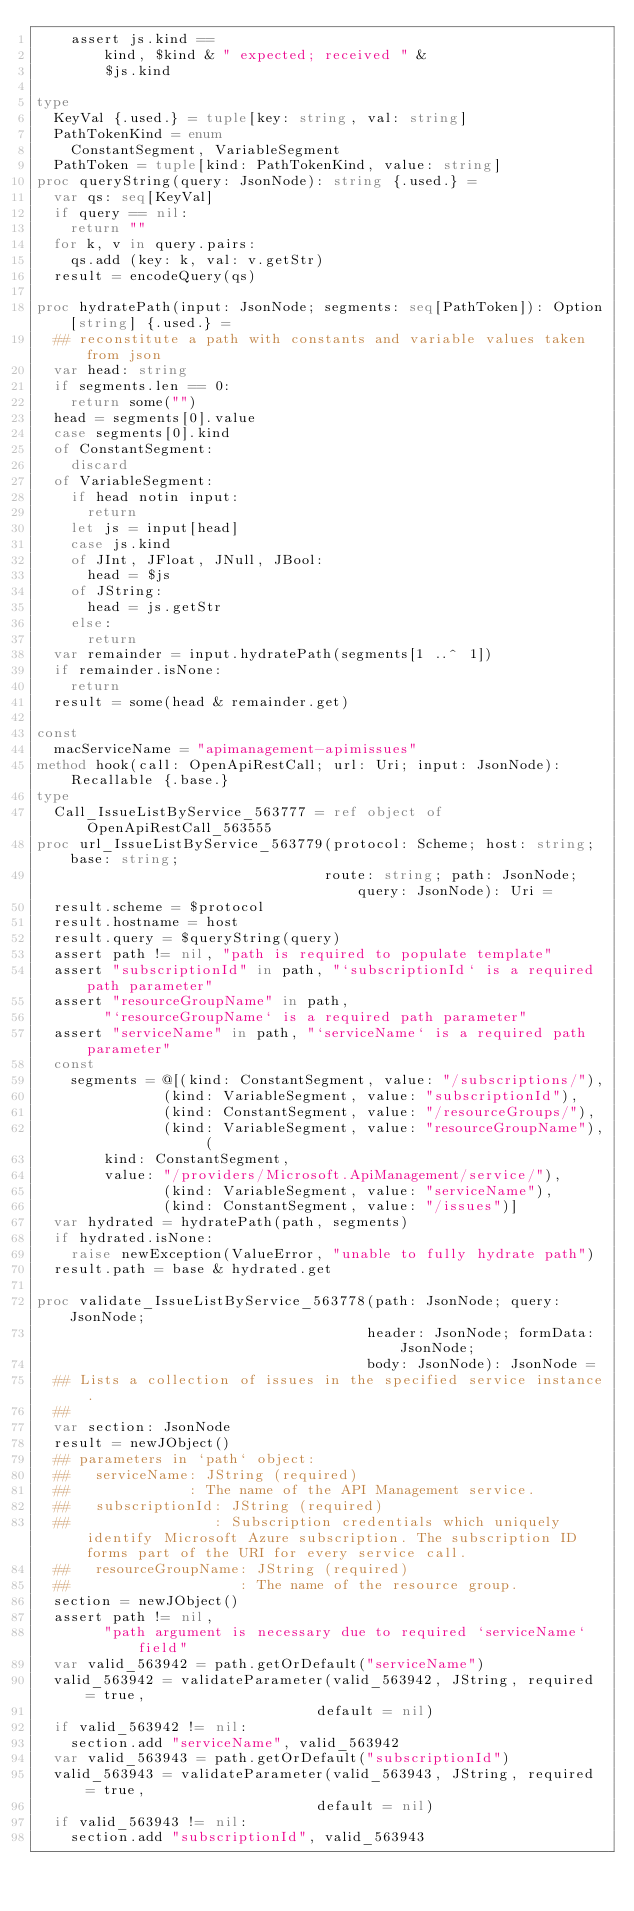Convert code to text. <code><loc_0><loc_0><loc_500><loc_500><_Nim_>    assert js.kind ==
        kind, $kind & " expected; received " &
        $js.kind

type
  KeyVal {.used.} = tuple[key: string, val: string]
  PathTokenKind = enum
    ConstantSegment, VariableSegment
  PathToken = tuple[kind: PathTokenKind, value: string]
proc queryString(query: JsonNode): string {.used.} =
  var qs: seq[KeyVal]
  if query == nil:
    return ""
  for k, v in query.pairs:
    qs.add (key: k, val: v.getStr)
  result = encodeQuery(qs)

proc hydratePath(input: JsonNode; segments: seq[PathToken]): Option[string] {.used.} =
  ## reconstitute a path with constants and variable values taken from json
  var head: string
  if segments.len == 0:
    return some("")
  head = segments[0].value
  case segments[0].kind
  of ConstantSegment:
    discard
  of VariableSegment:
    if head notin input:
      return
    let js = input[head]
    case js.kind
    of JInt, JFloat, JNull, JBool:
      head = $js
    of JString:
      head = js.getStr
    else:
      return
  var remainder = input.hydratePath(segments[1 ..^ 1])
  if remainder.isNone:
    return
  result = some(head & remainder.get)

const
  macServiceName = "apimanagement-apimissues"
method hook(call: OpenApiRestCall; url: Uri; input: JsonNode): Recallable {.base.}
type
  Call_IssueListByService_563777 = ref object of OpenApiRestCall_563555
proc url_IssueListByService_563779(protocol: Scheme; host: string; base: string;
                                  route: string; path: JsonNode; query: JsonNode): Uri =
  result.scheme = $protocol
  result.hostname = host
  result.query = $queryString(query)
  assert path != nil, "path is required to populate template"
  assert "subscriptionId" in path, "`subscriptionId` is a required path parameter"
  assert "resourceGroupName" in path,
        "`resourceGroupName` is a required path parameter"
  assert "serviceName" in path, "`serviceName` is a required path parameter"
  const
    segments = @[(kind: ConstantSegment, value: "/subscriptions/"),
               (kind: VariableSegment, value: "subscriptionId"),
               (kind: ConstantSegment, value: "/resourceGroups/"),
               (kind: VariableSegment, value: "resourceGroupName"), (
        kind: ConstantSegment,
        value: "/providers/Microsoft.ApiManagement/service/"),
               (kind: VariableSegment, value: "serviceName"),
               (kind: ConstantSegment, value: "/issues")]
  var hydrated = hydratePath(path, segments)
  if hydrated.isNone:
    raise newException(ValueError, "unable to fully hydrate path")
  result.path = base & hydrated.get

proc validate_IssueListByService_563778(path: JsonNode; query: JsonNode;
                                       header: JsonNode; formData: JsonNode;
                                       body: JsonNode): JsonNode =
  ## Lists a collection of issues in the specified service instance.
  ## 
  var section: JsonNode
  result = newJObject()
  ## parameters in `path` object:
  ##   serviceName: JString (required)
  ##              : The name of the API Management service.
  ##   subscriptionId: JString (required)
  ##                 : Subscription credentials which uniquely identify Microsoft Azure subscription. The subscription ID forms part of the URI for every service call.
  ##   resourceGroupName: JString (required)
  ##                    : The name of the resource group.
  section = newJObject()
  assert path != nil,
        "path argument is necessary due to required `serviceName` field"
  var valid_563942 = path.getOrDefault("serviceName")
  valid_563942 = validateParameter(valid_563942, JString, required = true,
                                 default = nil)
  if valid_563942 != nil:
    section.add "serviceName", valid_563942
  var valid_563943 = path.getOrDefault("subscriptionId")
  valid_563943 = validateParameter(valid_563943, JString, required = true,
                                 default = nil)
  if valid_563943 != nil:
    section.add "subscriptionId", valid_563943</code> 